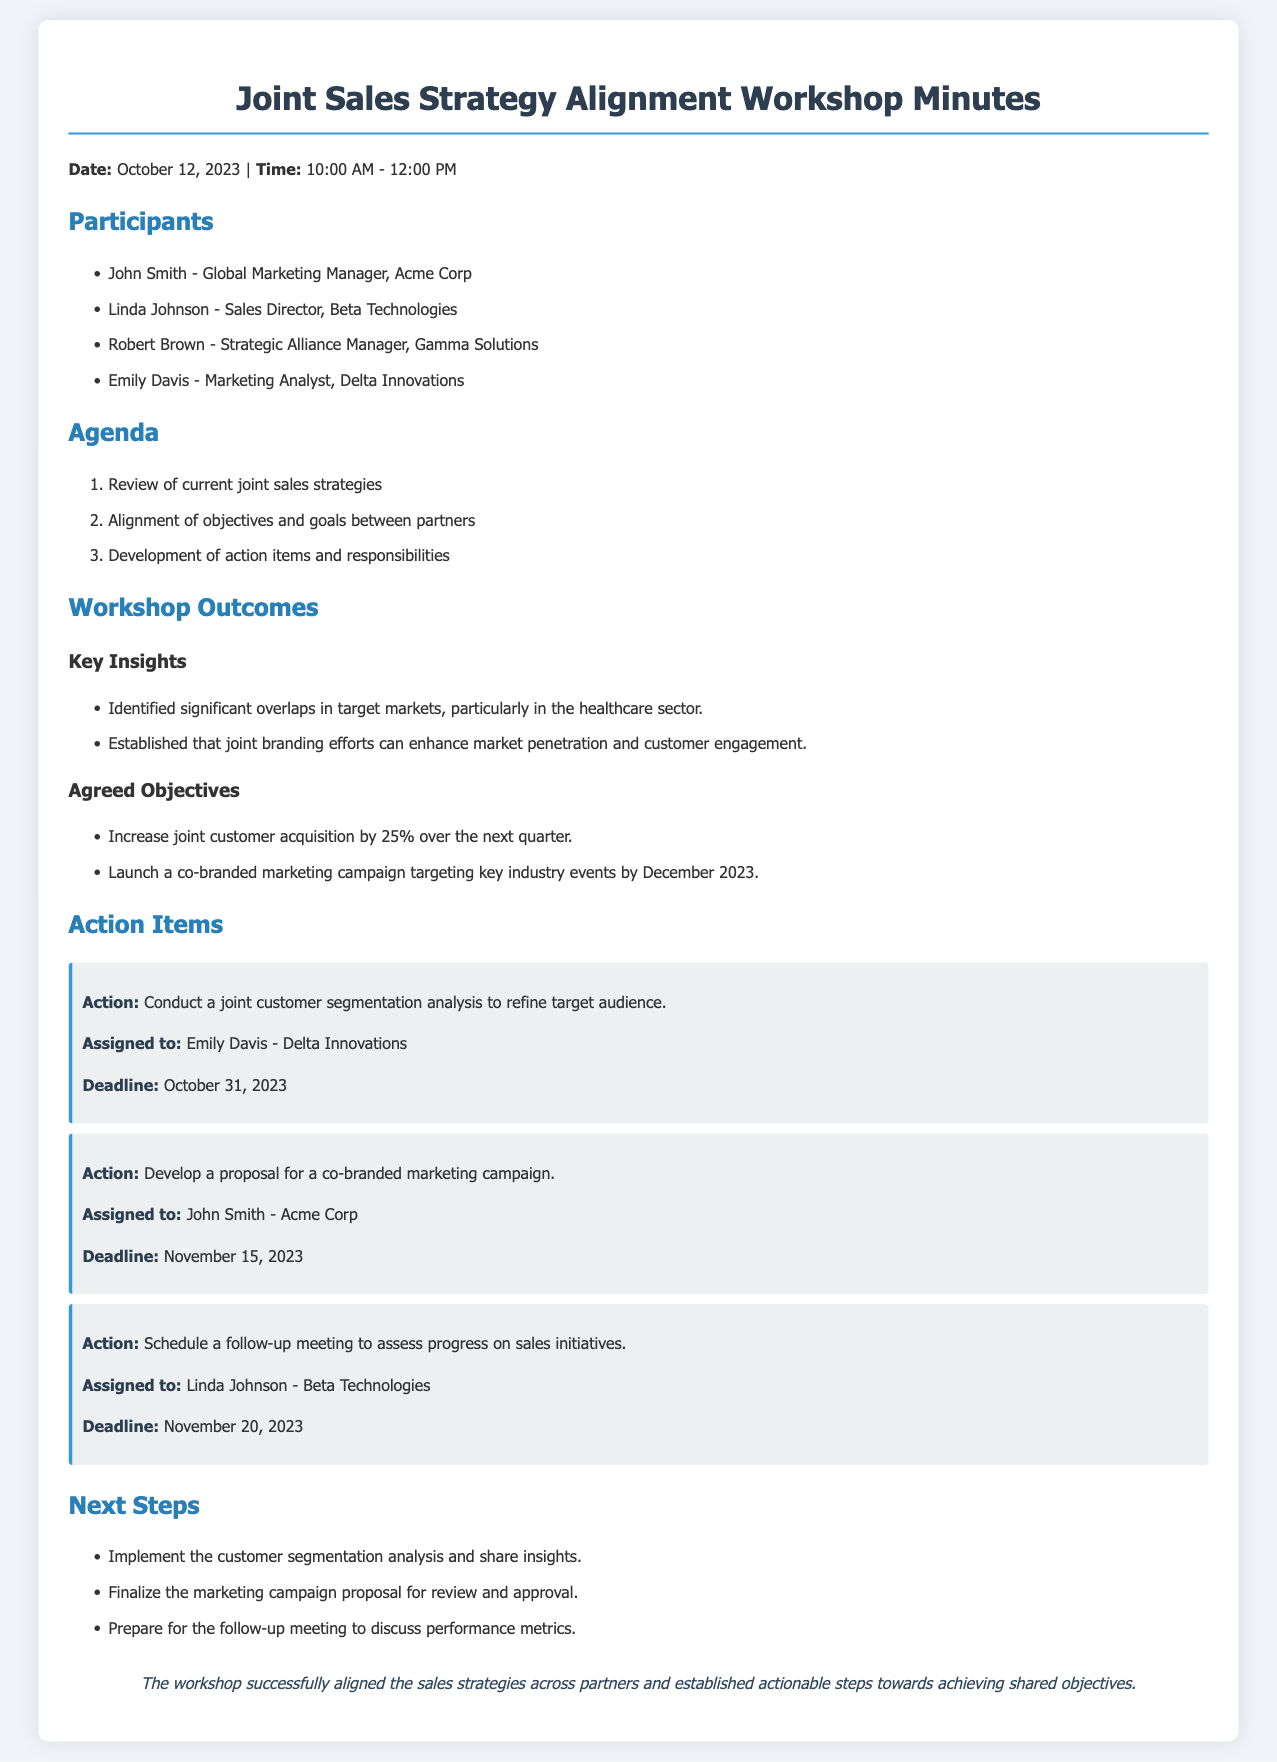what was the date of the workshop? The date of the workshop is specified in the document header.
Answer: October 12, 2023 who is assigned to conduct a joint customer segmentation analysis? This is mentioned in the action items section where responsibilities are assigned.
Answer: Emily Davis - Delta Innovations what is the deadline for the co-branded marketing campaign proposal? The deadline for the proposal is detailed in the action items list.
Answer: November 15, 2023 what percentage increase in customer acquisition is targeted? This goal is stated under the agreed objectives section of the outcomes.
Answer: 25% what is one of the key insights from the workshop? Key insights are listed under the workshop outcomes, highlighting specific findings.
Answer: Significant overlaps in target markets who will schedule the follow-up meeting? This detail is found in the action items, specifying who is responsible for scheduling.
Answer: Linda Johnson - Beta Technologies what is the objective regarding the co-branded marketing campaign launch? The objective is listed among the agreed objectives outlined in the document.
Answer: By December 2023 how many participants attended the workshop? Participants are listed at the beginning of the document, and counting them provides the total.
Answer: Four 